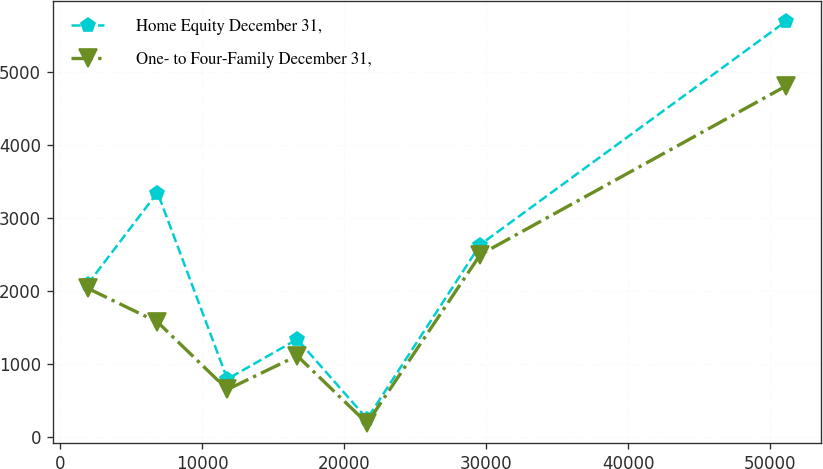Convert chart to OTSL. <chart><loc_0><loc_0><loc_500><loc_500><line_chart><ecel><fcel>Home Equity December 31,<fcel>One- to Four-Family December 31,<nl><fcel>1938.75<fcel>2089.46<fcel>2034.94<nl><fcel>6858.84<fcel>3346<fcel>1573.02<nl><fcel>11778.9<fcel>792.19<fcel>649.18<nl><fcel>16699<fcel>1336.78<fcel>1111.1<nl><fcel>21619.1<fcel>247.6<fcel>187.26<nl><fcel>29594.1<fcel>2634.05<fcel>2496.86<nl><fcel>51139.6<fcel>5693.53<fcel>4806.43<nl></chart> 